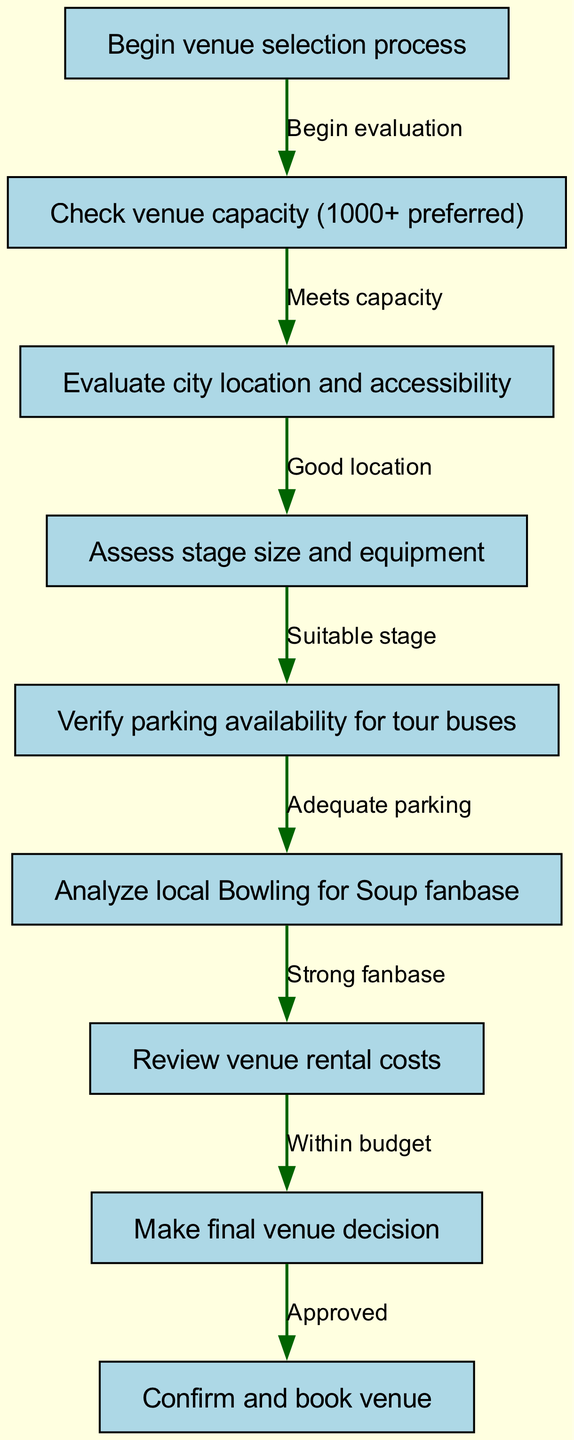What is the first step in the venue selection process? The first step, represented by the "start" node, states "Begin venue selection process." Thus, this marks the initiation of the overall process.
Answer: Begin venue selection process How many total nodes are present in the diagram? By counting all nodes outlined in the data section, we find there are nine distinct nodes that represent steps or stages in the selection process.
Answer: 9 What node comes after assessing stage size and equipment? According to the directed flow, after the "Assess stage size and equipment" node, which corresponds to the "stage" node, the next step is “Verify parking availability for tour buses."
Answer: Verify parking availability for tour buses What is the final decision in the venue selection process? The final node leads to, "Confirm and book venue," indicating that this action is taken after all previous decisions and evaluations in the process have been completed.
Answer: Confirm and book venue How many edges connect the nodes in this diagram? The edges represent the connections between nodes, and upon reviewing the data, it can be concluded that there are eight unique edges that depict the flow of the venue selection process.
Answer: 8 Which node is reached if the venue does not meet the capacity? In the diagram, if a venue does not meet the capacity requirements, the process would presumably end as there is no direct edge indicating an alternative route after the "Check venue capacity (1000+ preferred)" step.
Answer: No alternative route What is evaluated after checking parking availability? Following the verification of parking availability, the next item to evaluate is the "Analyze local Bowling for Soup fanbase," continuing the logical sequence of the selection criteria.
Answer: Analyze local Bowling for Soup fanbase What type of venue rental cost is required to move to the final decision? The flowchart indicates that the venue's rental costs must be "Within budget" to progress from the "Review venue rental costs" to the "Make final venue decision."
Answer: Within budget 